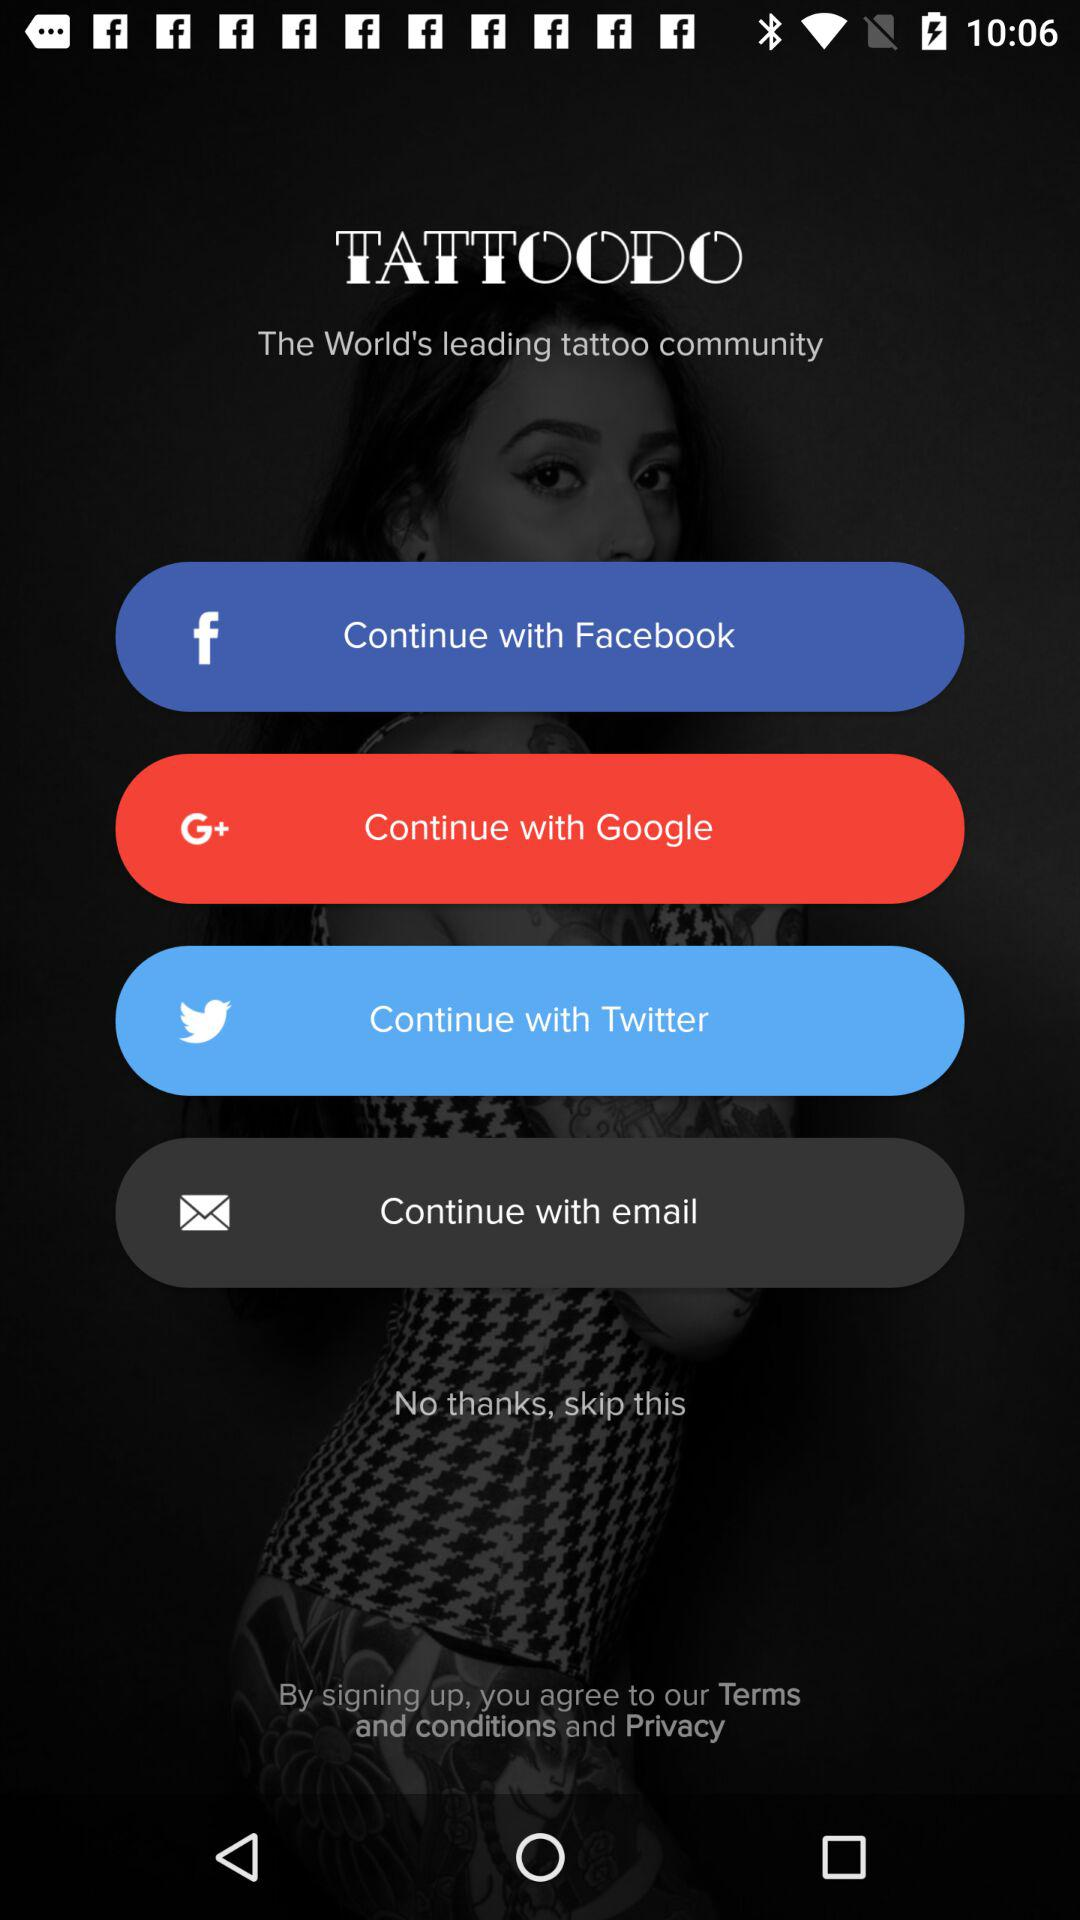Which applications can be used to log in? The applications that can be used to log in are "Facebook", "Google" and "Twitter". 